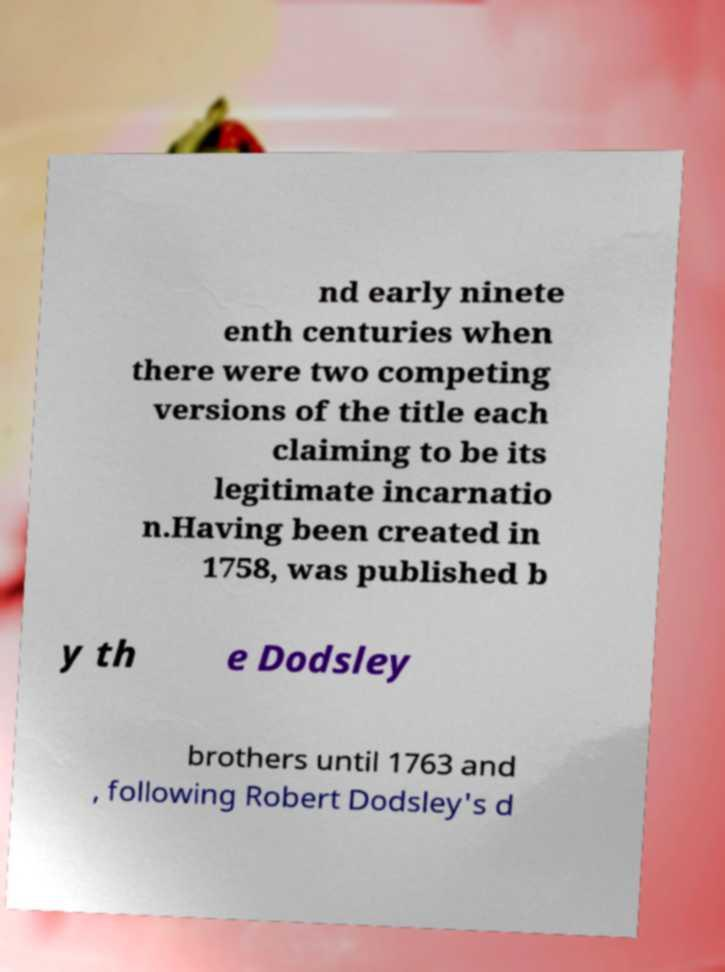Can you read and provide the text displayed in the image?This photo seems to have some interesting text. Can you extract and type it out for me? nd early ninete enth centuries when there were two competing versions of the title each claiming to be its legitimate incarnatio n.Having been created in 1758, was published b y th e Dodsley brothers until 1763 and , following Robert Dodsley's d 